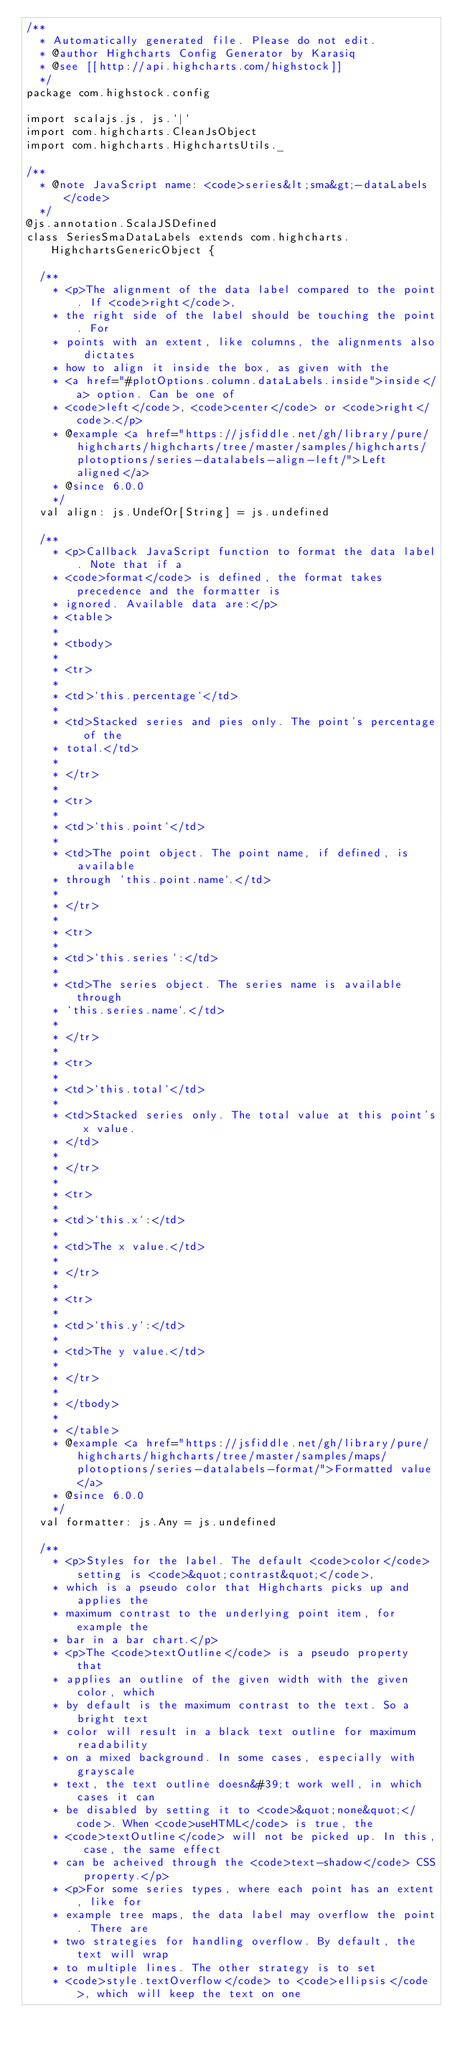<code> <loc_0><loc_0><loc_500><loc_500><_Scala_>/**
  * Automatically generated file. Please do not edit.
  * @author Highcharts Config Generator by Karasiq
  * @see [[http://api.highcharts.com/highstock]]
  */
package com.highstock.config

import scalajs.js, js.`|`
import com.highcharts.CleanJsObject
import com.highcharts.HighchartsUtils._

/**
  * @note JavaScript name: <code>series&lt;sma&gt;-dataLabels</code>
  */
@js.annotation.ScalaJSDefined
class SeriesSmaDataLabels extends com.highcharts.HighchartsGenericObject {

  /**
    * <p>The alignment of the data label compared to the point. If <code>right</code>,
    * the right side of the label should be touching the point. For
    * points with an extent, like columns, the alignments also dictates
    * how to align it inside the box, as given with the
    * <a href="#plotOptions.column.dataLabels.inside">inside</a> option. Can be one of
    * <code>left</code>, <code>center</code> or <code>right</code>.</p>
    * @example <a href="https://jsfiddle.net/gh/library/pure/highcharts/highcharts/tree/master/samples/highcharts/plotoptions/series-datalabels-align-left/">Left aligned</a>
    * @since 6.0.0
    */
  val align: js.UndefOr[String] = js.undefined

  /**
    * <p>Callback JavaScript function to format the data label. Note that if a
    * <code>format</code> is defined, the format takes precedence and the formatter is
    * ignored. Available data are:</p>
    * <table>
    * 
    * <tbody>
    * 
    * <tr>
    * 
    * <td>`this.percentage`</td>
    * 
    * <td>Stacked series and pies only. The point's percentage of the
    * total.</td>
    * 
    * </tr>
    * 
    * <tr>
    * 
    * <td>`this.point`</td>
    * 
    * <td>The point object. The point name, if defined, is available
    * through `this.point.name`.</td>
    * 
    * </tr>
    * 
    * <tr>
    * 
    * <td>`this.series`:</td>
    * 
    * <td>The series object. The series name is available through
    * `this.series.name`.</td>
    * 
    * </tr>
    * 
    * <tr>
    * 
    * <td>`this.total`</td>
    * 
    * <td>Stacked series only. The total value at this point's x value.
    * </td>
    * 
    * </tr>
    * 
    * <tr>
    * 
    * <td>`this.x`:</td>
    * 
    * <td>The x value.</td>
    * 
    * </tr>
    * 
    * <tr>
    * 
    * <td>`this.y`:</td>
    * 
    * <td>The y value.</td>
    * 
    * </tr>
    * 
    * </tbody>
    * 
    * </table>
    * @example <a href="https://jsfiddle.net/gh/library/pure/highcharts/highcharts/tree/master/samples/maps/plotoptions/series-datalabels-format/">Formatted value</a>
    * @since 6.0.0
    */
  val formatter: js.Any = js.undefined

  /**
    * <p>Styles for the label. The default <code>color</code> setting is <code>&quot;contrast&quot;</code>,
    * which is a pseudo color that Highcharts picks up and applies the
    * maximum contrast to the underlying point item, for example the
    * bar in a bar chart.</p>
    * <p>The <code>textOutline</code> is a pseudo property that
    * applies an outline of the given width with the given color, which
    * by default is the maximum contrast to the text. So a bright text
    * color will result in a black text outline for maximum readability
    * on a mixed background. In some cases, especially with grayscale
    * text, the text outline doesn&#39;t work well, in which cases it can
    * be disabled by setting it to <code>&quot;none&quot;</code>. When <code>useHTML</code> is true, the
    * <code>textOutline</code> will not be picked up. In this, case, the same effect
    * can be acheived through the <code>text-shadow</code> CSS property.</p>
    * <p>For some series types, where each point has an extent, like for
    * example tree maps, the data label may overflow the point. There are
    * two strategies for handling overflow. By default, the text will wrap
    * to multiple lines. The other strategy is to set
    * <code>style.textOverflow</code> to <code>ellipsis</code>, which will keep the text on one</code> 